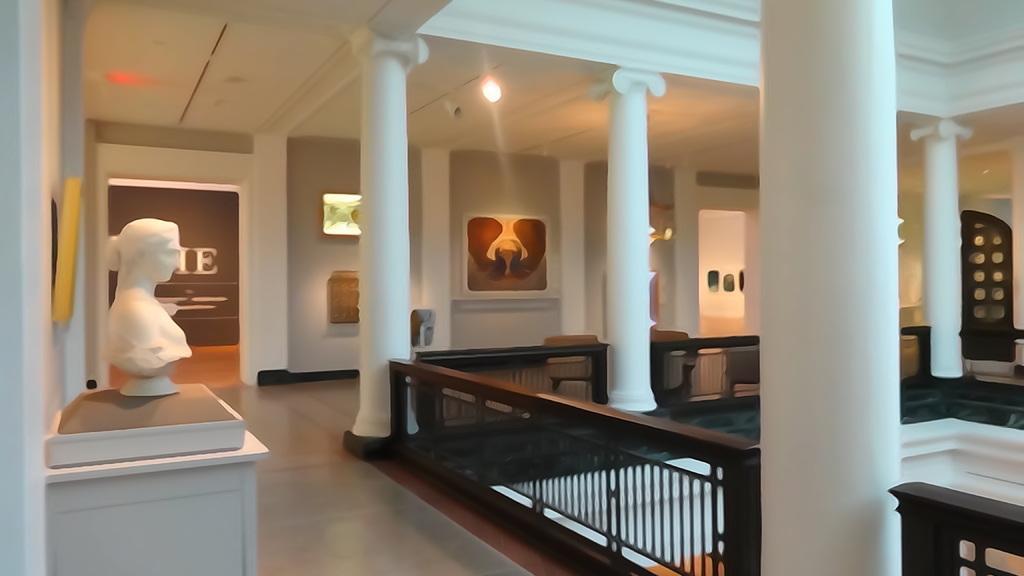Can you describe this image briefly? In this image we can see some pillars, fencing, some chairs and there is a sculpture of a lady person on table and in the background of the image there is a wall to which some paintings attached. 